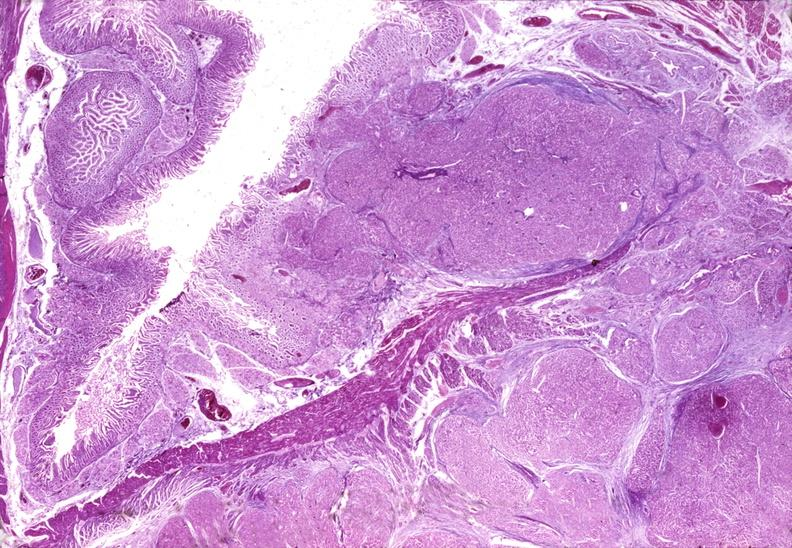where is this?
Answer the question using a single word or phrase. Pancreas 